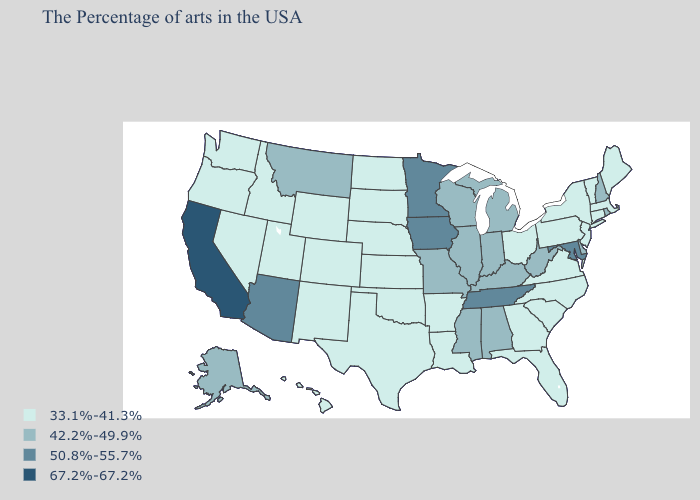Does Alaska have the lowest value in the USA?
Answer briefly. No. Name the states that have a value in the range 67.2%-67.2%?
Concise answer only. California. Name the states that have a value in the range 33.1%-41.3%?
Keep it brief. Maine, Massachusetts, Vermont, Connecticut, New York, New Jersey, Pennsylvania, Virginia, North Carolina, South Carolina, Ohio, Florida, Georgia, Louisiana, Arkansas, Kansas, Nebraska, Oklahoma, Texas, South Dakota, North Dakota, Wyoming, Colorado, New Mexico, Utah, Idaho, Nevada, Washington, Oregon, Hawaii. Does Maine have a higher value than Alabama?
Quick response, please. No. Name the states that have a value in the range 42.2%-49.9%?
Give a very brief answer. Rhode Island, New Hampshire, Delaware, West Virginia, Michigan, Kentucky, Indiana, Alabama, Wisconsin, Illinois, Mississippi, Missouri, Montana, Alaska. Does the first symbol in the legend represent the smallest category?
Concise answer only. Yes. What is the value of Maine?
Keep it brief. 33.1%-41.3%. Name the states that have a value in the range 42.2%-49.9%?
Quick response, please. Rhode Island, New Hampshire, Delaware, West Virginia, Michigan, Kentucky, Indiana, Alabama, Wisconsin, Illinois, Mississippi, Missouri, Montana, Alaska. What is the lowest value in the West?
Write a very short answer. 33.1%-41.3%. What is the highest value in states that border Delaware?
Keep it brief. 50.8%-55.7%. What is the value of Kentucky?
Give a very brief answer. 42.2%-49.9%. What is the value of South Carolina?
Quick response, please. 33.1%-41.3%. Does California have the highest value in the West?
Write a very short answer. Yes. Among the states that border Missouri , which have the highest value?
Keep it brief. Tennessee, Iowa. Among the states that border Utah , does Idaho have the highest value?
Write a very short answer. No. 